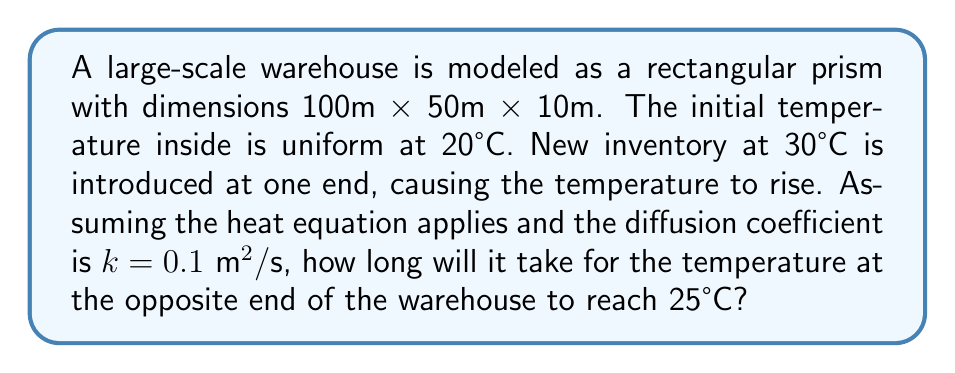Give your solution to this math problem. To solve this problem, we'll use the one-dimensional heat equation:

$$\frac{\partial T}{\partial t} = k\frac{\partial^2 T}{\partial x^2}$$

Where $T$ is temperature, $t$ is time, $x$ is distance, and $k$ is the diffusion coefficient.

1) The longest dimension of the warehouse is 100m, so we'll focus on this axis.

2) The boundary conditions are:
   $T(0,t) = 30°C$ (new inventory end)
   $T(100,0) = 20°C$ (initial temperature at the opposite end)

3) We're interested in when $T(100,t) = 25°C$

4) The solution to the heat equation in this case is:

   $$T(x,t) = 30 - 10\text{erf}\left(\frac{x}{2\sqrt{kt}}\right)$$

   Where erf is the error function.

5) At $x = 100$ and $T = 25$, we have:

   $$25 = 30 - 10\text{erf}\left(\frac{100}{2\sqrt{0.1t}}\right)$$

6) Solving for the error function:

   $$\text{erf}\left(\frac{100}{2\sqrt{0.1t}}\right) = 0.5$$

7) The inverse error function of 0.5 is approximately 0.4769:

   $$\frac{100}{2\sqrt{0.1t}} = 0.4769$$

8) Solving for $t$:

   $$t = \frac{100^2}{4 \cdot 0.1 \cdot 0.4769^2} \approx 109,720 \text{ seconds}$$

9) Converting to hours:

   $$109,720 \text{ seconds} \approx 30.48 \text{ hours}$$
Answer: 30.48 hours 